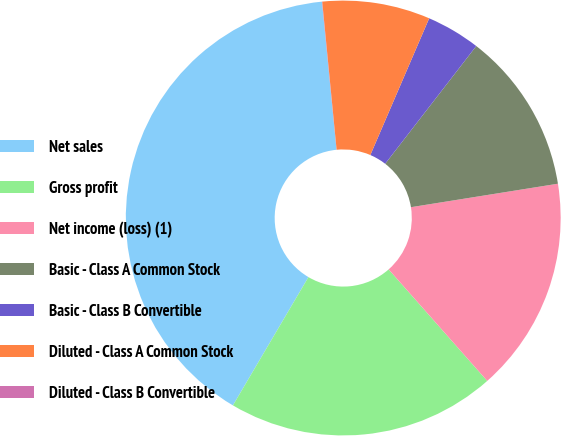Convert chart to OTSL. <chart><loc_0><loc_0><loc_500><loc_500><pie_chart><fcel>Net sales<fcel>Gross profit<fcel>Net income (loss) (1)<fcel>Basic - Class A Common Stock<fcel>Basic - Class B Convertible<fcel>Diluted - Class A Common Stock<fcel>Diluted - Class B Convertible<nl><fcel>39.97%<fcel>19.99%<fcel>16.0%<fcel>12.0%<fcel>4.01%<fcel>8.01%<fcel>0.02%<nl></chart> 